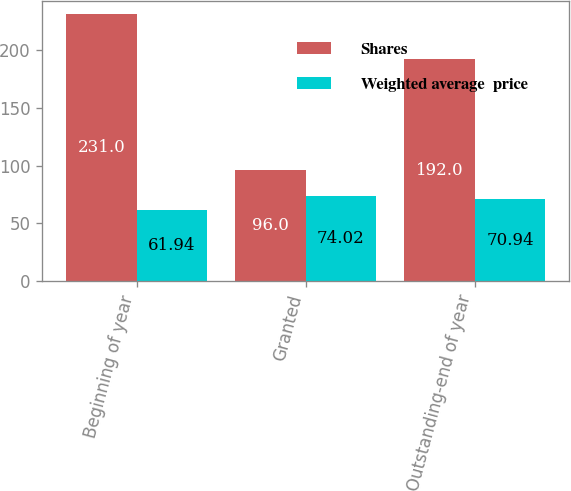<chart> <loc_0><loc_0><loc_500><loc_500><stacked_bar_chart><ecel><fcel>Beginning of year<fcel>Granted<fcel>Outstanding-end of year<nl><fcel>Shares<fcel>231<fcel>96<fcel>192<nl><fcel>Weighted average  price<fcel>61.94<fcel>74.02<fcel>70.94<nl></chart> 